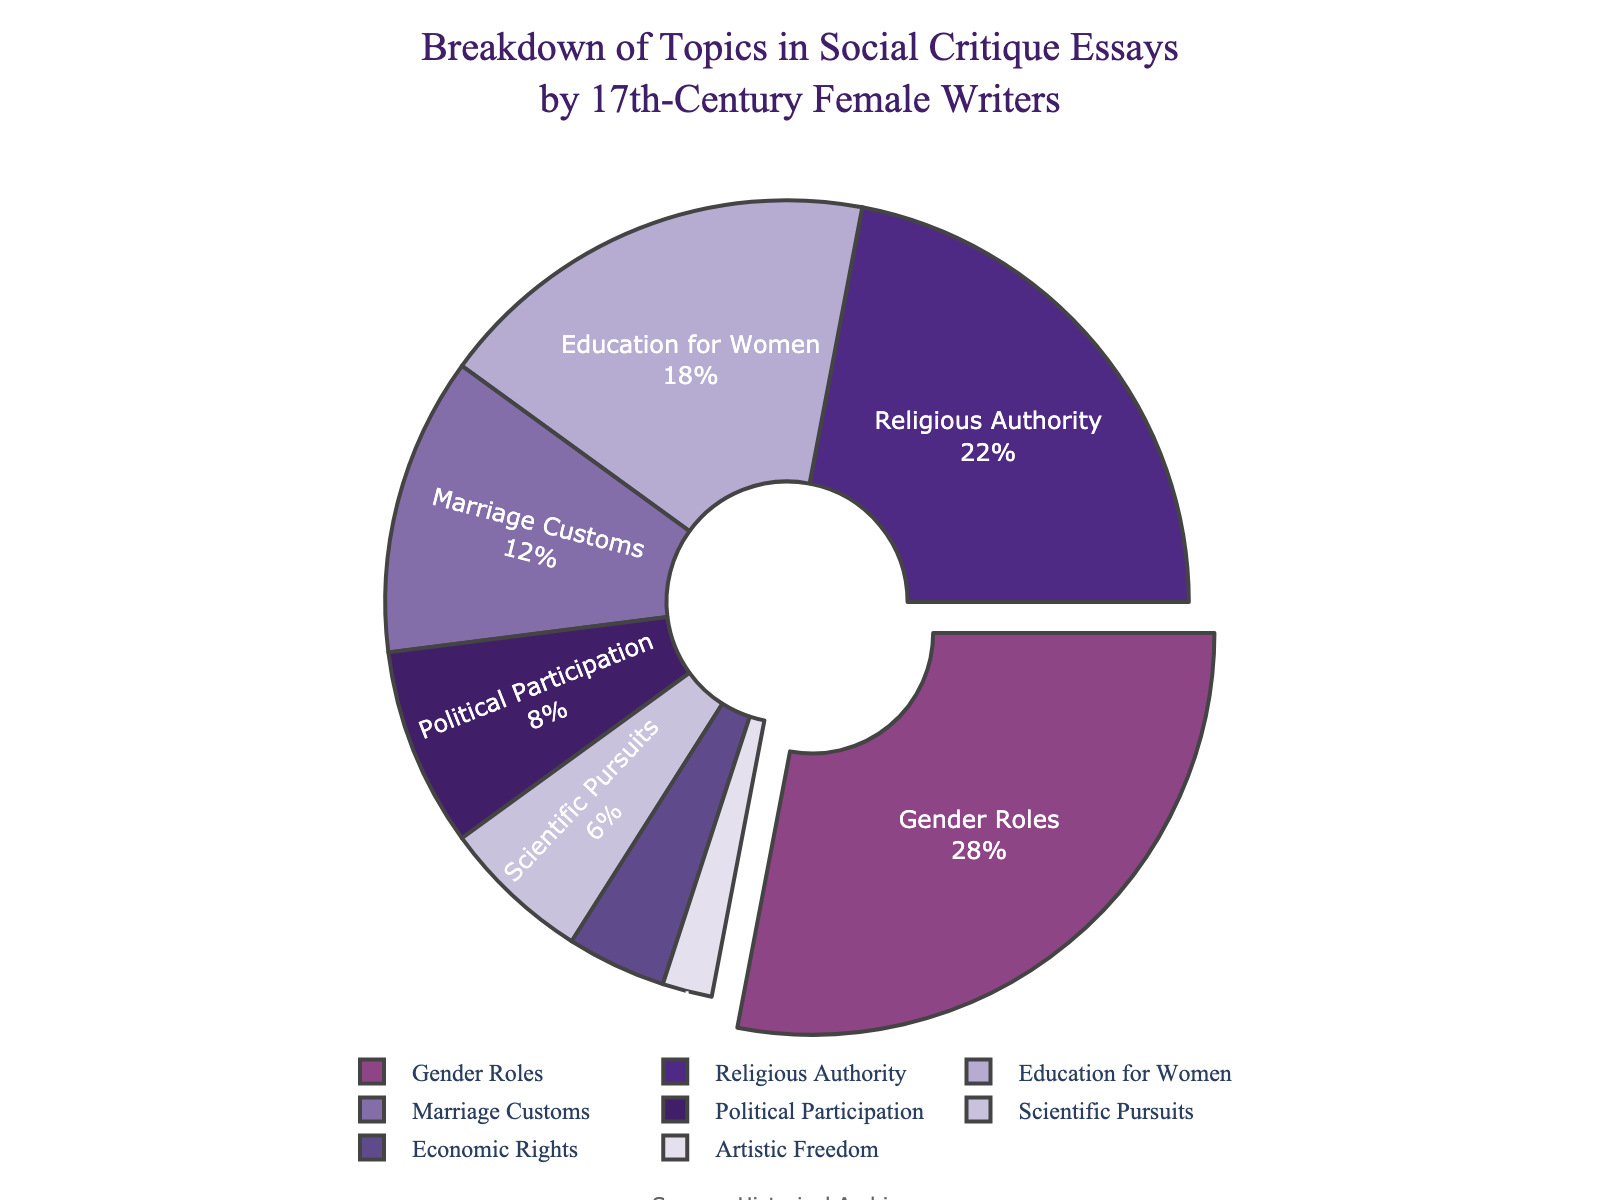Which topic is addressed most frequently in the social critique essays? The pie chart shows the percentage breakdown of topics addressed. The largest section corresponds to Gender Roles with 28%.
Answer: Gender Roles What is the combined percentage for Education for Women and Political Participation? Add the percentages for Education for Women (18%) and Political Participation (8%): 18 + 8 = 26%.
Answer: 26% Is Religious Authority addressed more frequently than Marriage Customs? Compare the percentages for Religious Authority (22%) and Marriage Customs (12%). 22% is greater than 12%.
Answer: Yes Which topic has the smallest representation in the essays? The smallest segment in the pie chart is Artistic Freedom at 2%.
Answer: Artistic Freedom Is the share of essays discussing Economic Rights greater than that discussing Scientific Pursuits? Compare the percentages for Economic Rights (4%) and Scientific Pursuits (6%). 4% is less than 6%.
Answer: No What is the difference in percentage between the most frequently and least frequently addressed topics? The most frequently addressed topic is Gender Roles (28%) and the least is Artistic Freedom (2%). The difference is 28 - 2 = 26%.
Answer: 26% How many topics have a representation greater than 20%? Only Gender Roles (28%) and Religious Authority (22%) have representations greater than 20%. Therefore, there are 2 topics.
Answer: 2 What is the average percentage for the topics related to Education for Women, Marriage Customs, and Scientific Pursuits? Add the percentages for Education for Women (18%), Marriage Customs (12%), and Scientific Pursuits (6%), then divide by 3. (18 + 12 + 6) / 3 = 36 / 3 = 12%.
Answer: 12% Compare the combined percentages of Marriage Customs, Political Participation, and Economic Rights to that of Gender Roles. Which is higher? Combine the percentages for Marriage Customs (12%), Political Participation (8%), and Economic Rights (4%): 12 + 8 + 4 = 24%. Gender Roles alone is 28%, which is higher than 24%.
Answer: Gender Roles 